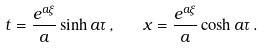Convert formula to latex. <formula><loc_0><loc_0><loc_500><loc_500>t = \frac { e ^ { a \xi } } { a } \sinh a \tau \, , \quad x = \frac { e ^ { a \xi } } { a } \cosh a \tau \, .</formula> 